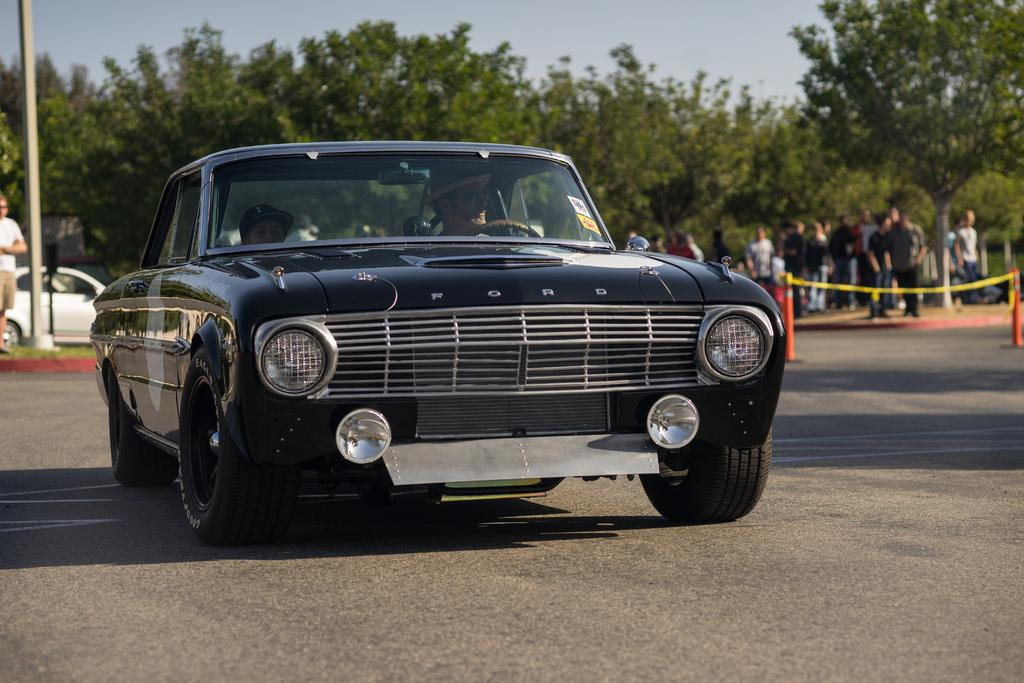What is the main subject in the center of the image? There is a car in the center of the image. Where is the car located? The car is on the road. Who is inside the car? There are persons in the car. What can be seen in the background of the image? There are persons, at least one other car, a pole, and trees in the background of the image. What type of pie is being served in the car? There is no pie present in the image; it features a car on the road with people inside. How many toes can be seen in the image? There are no visible toes in the image, as it focuses on a car and its surroundings. 